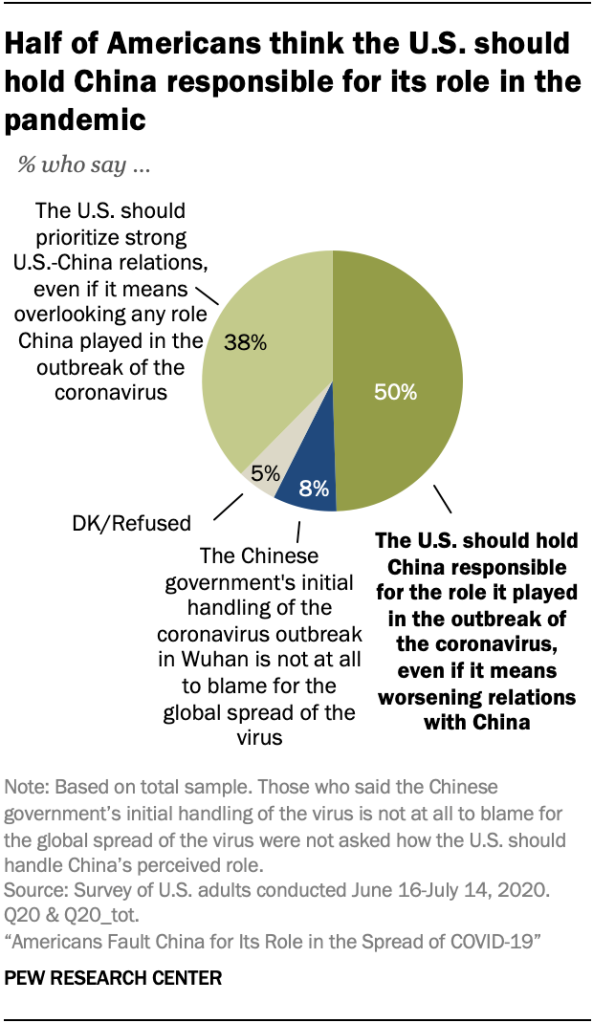Identify some key points in this picture. The color blue represents 8% in the pie segment. According to a recent survey, 50% of Americans believe that the United States should hold China accountable for its role in the outbreak of the coronavirus, even if it means damaging relations with China. 